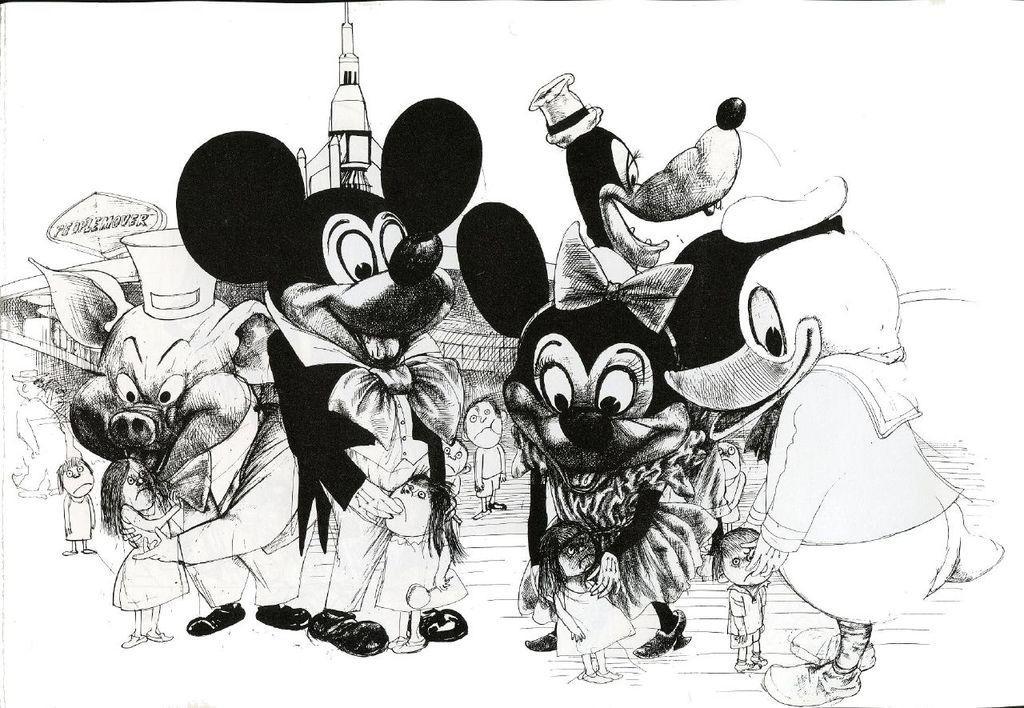In one or two sentences, can you explain what this image depicts? In this picture we can see cartoon images. Here we can see mickey mouse who is holding to the girl. In the back we can see building. Here we can see duck and pig. 